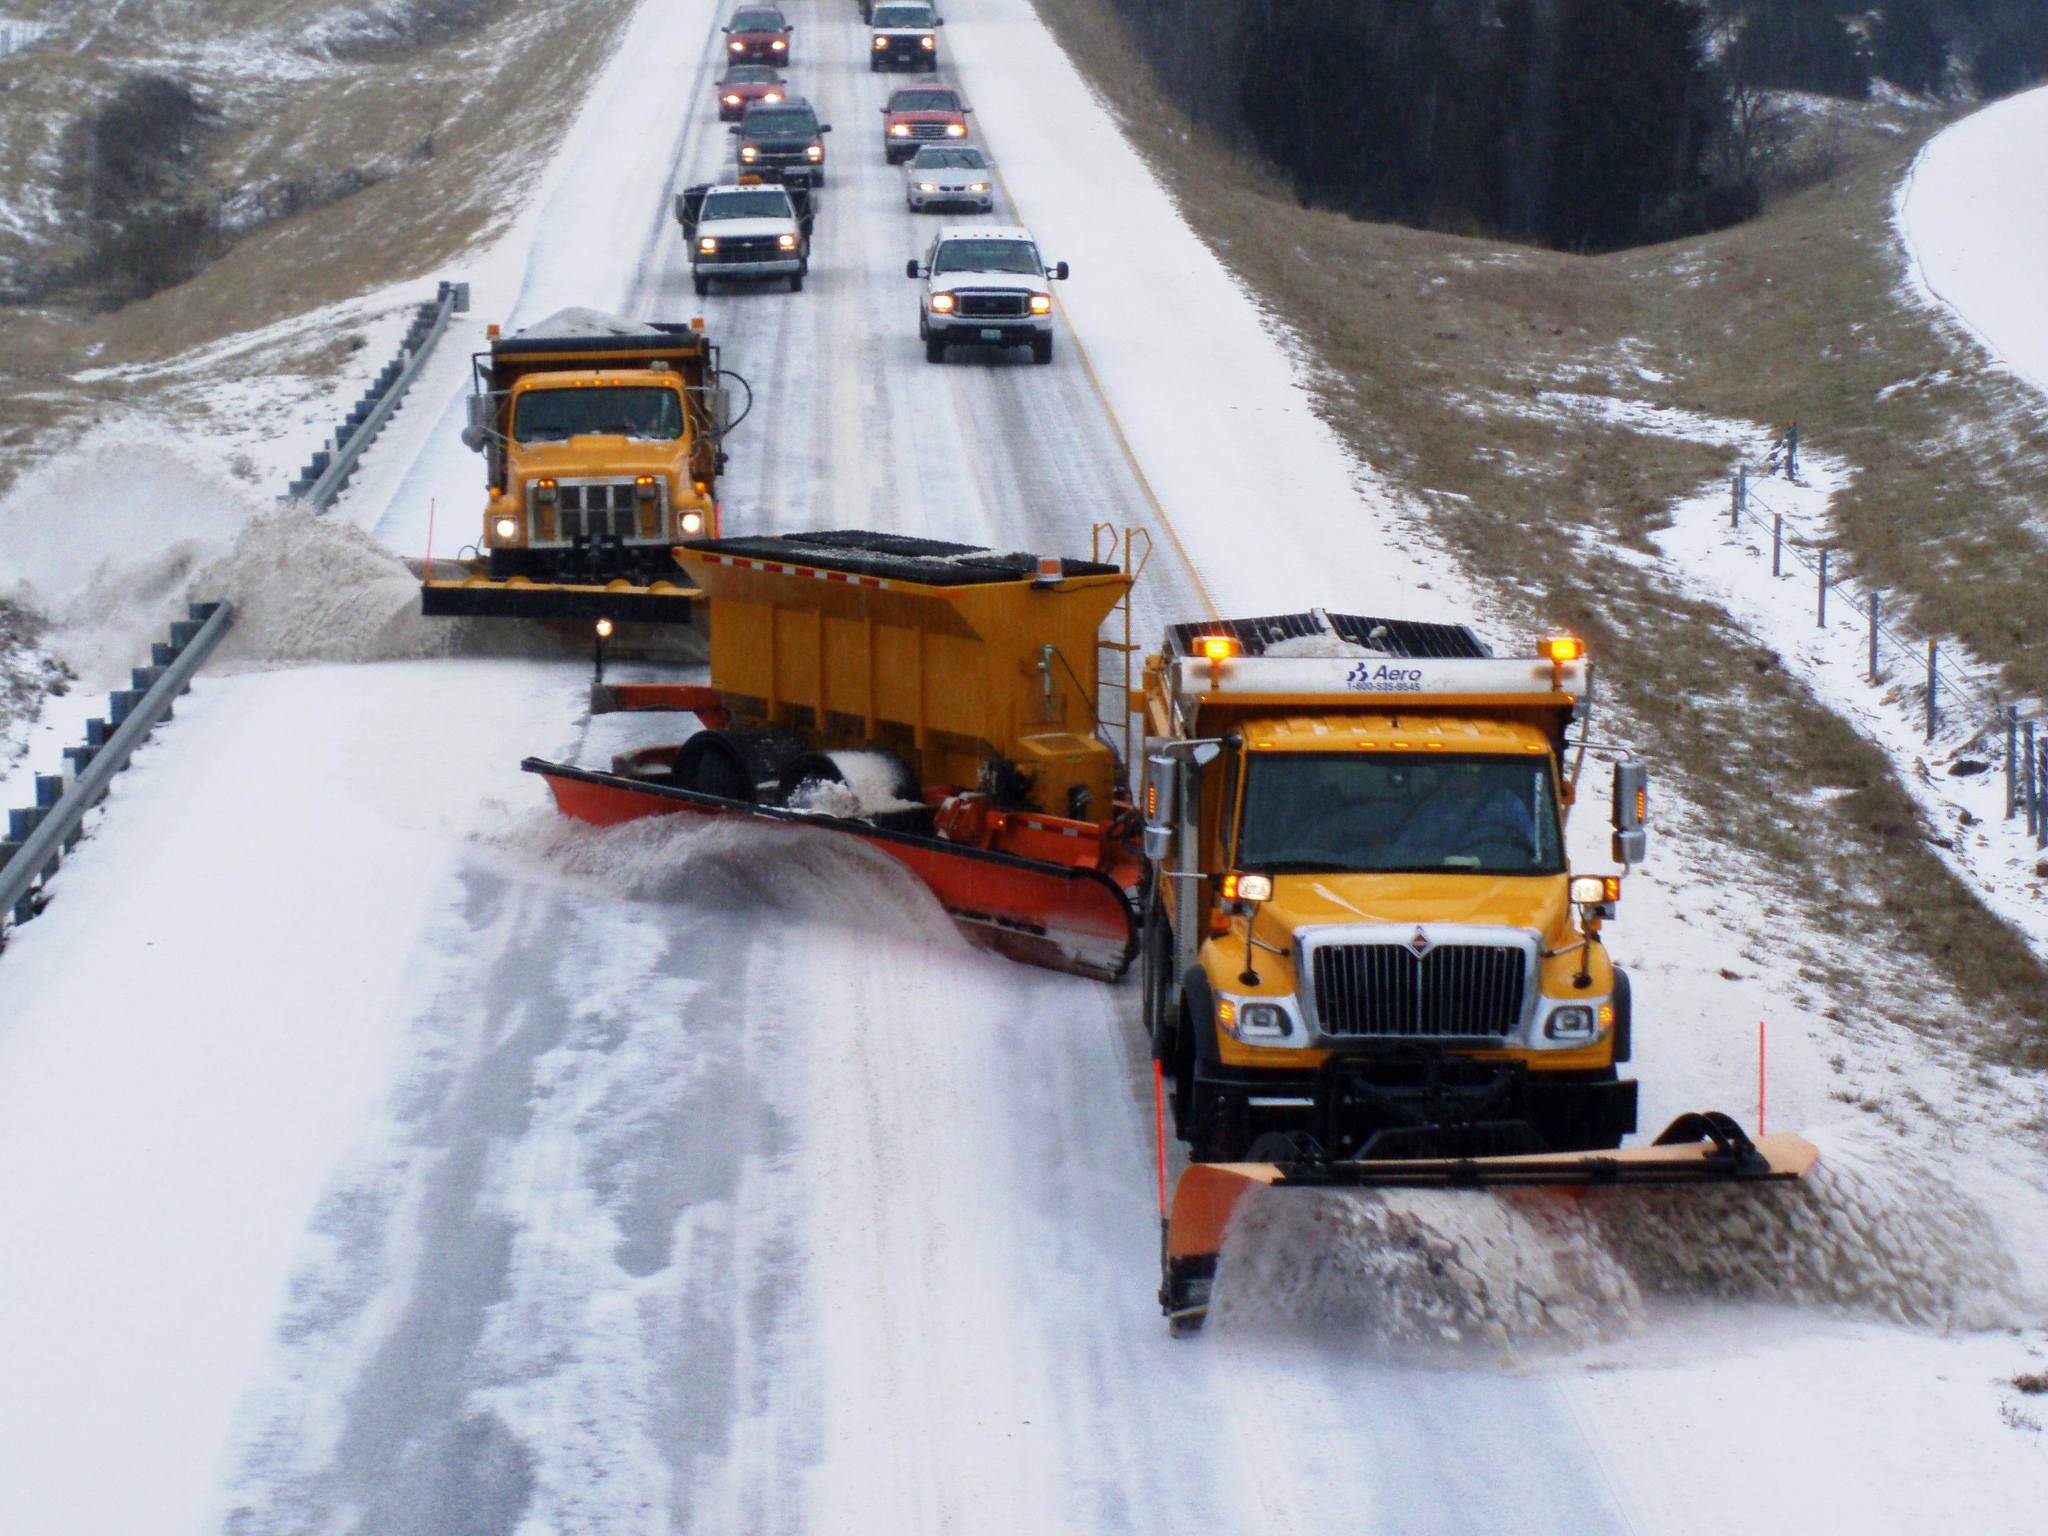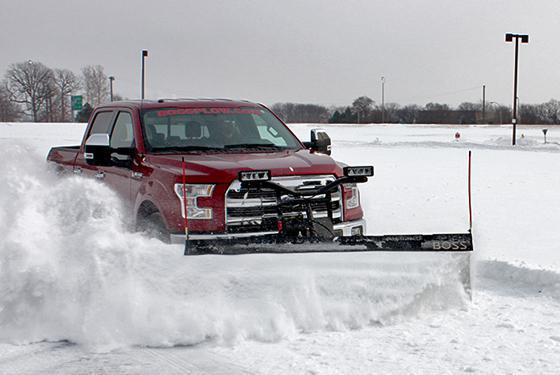The first image is the image on the left, the second image is the image on the right. For the images displayed, is the sentence "The left image contains at least two snow plows." factually correct? Answer yes or no. Yes. The first image is the image on the left, the second image is the image on the right. Analyze the images presented: Is the assertion "An image shows at least one yellow truck clearing snow with a plow." valid? Answer yes or no. Yes. 